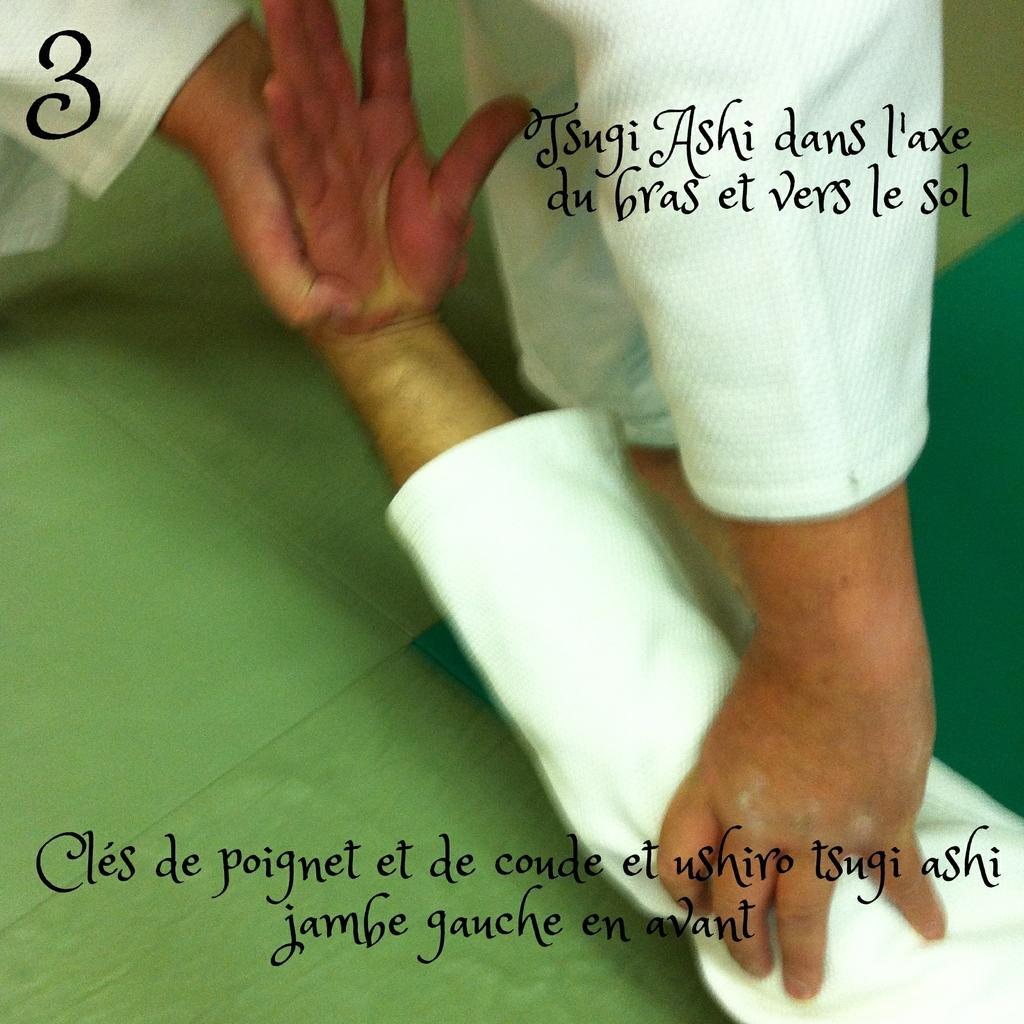How would you summarize this image in a sentence or two? In this image, we can see a person holding another person. We can see the ground and some text. 